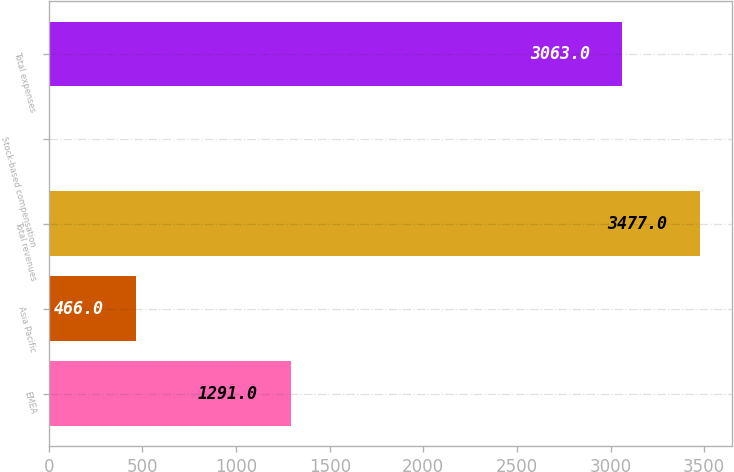Convert chart. <chart><loc_0><loc_0><loc_500><loc_500><bar_chart><fcel>EMEA<fcel>Asia Pacific<fcel>Total revenues<fcel>Stock-based compensation<fcel>Total expenses<nl><fcel>1291<fcel>466<fcel>3477<fcel>7<fcel>3063<nl></chart> 